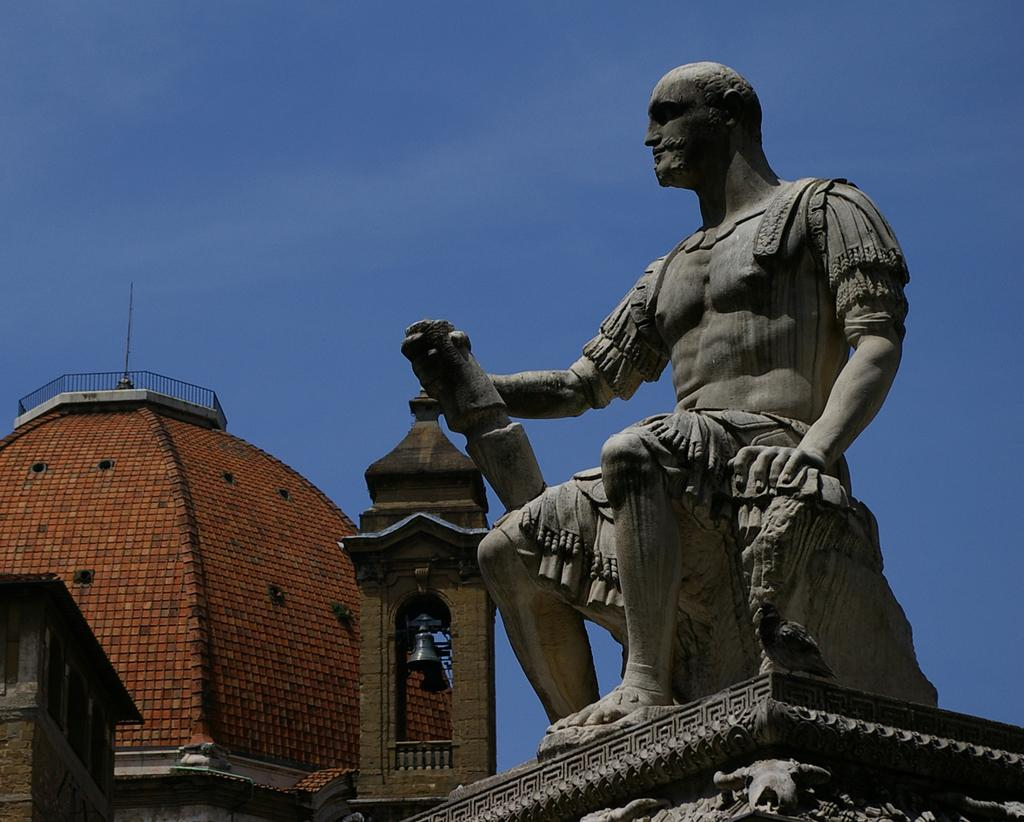What is the main subject of the image? There is a statue of a person sitting in the image. What can be seen in the background of the image? There is a building with railing in the background, and the sky is also visible. What other object is present in the image? There is a bell in the image. What type of pets can be seen playing with the bell in the image? There are no pets present in the image, and the bell is not being played with. 